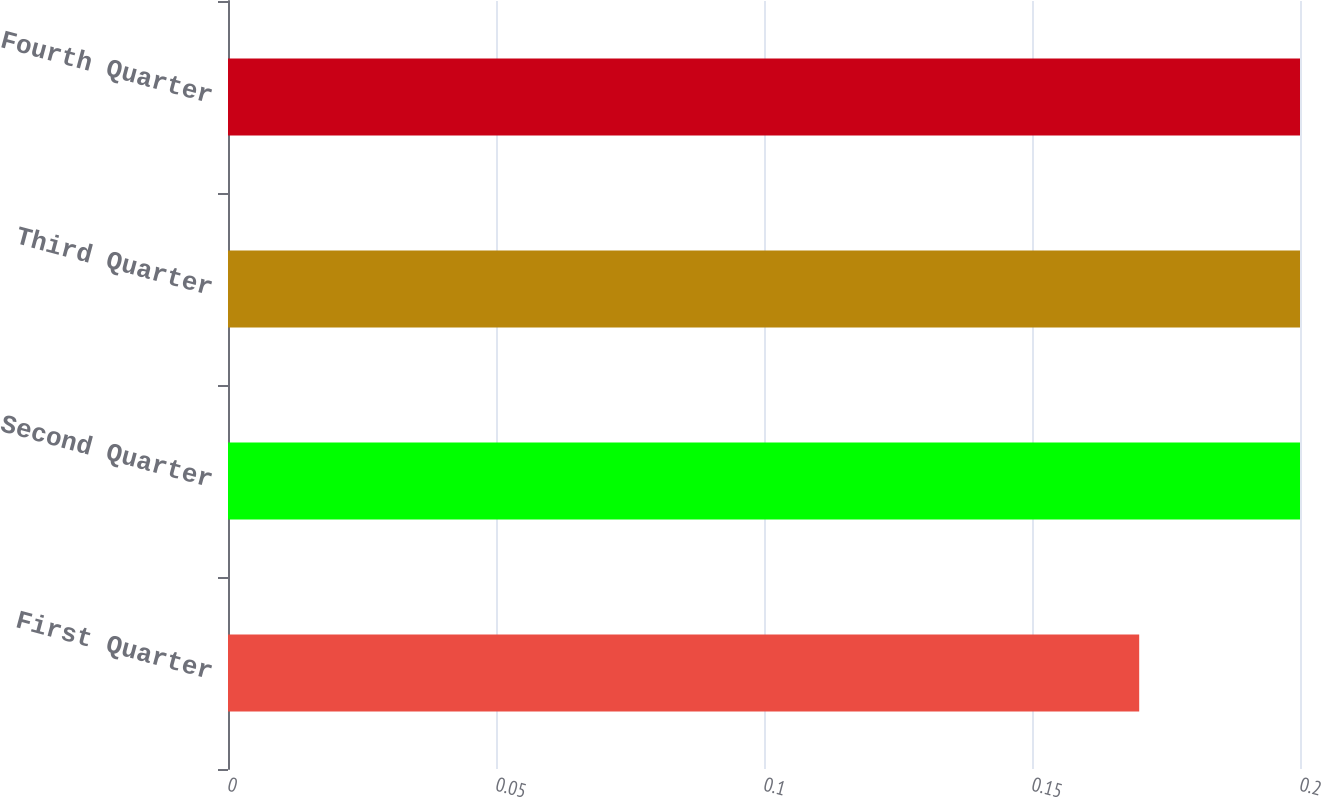<chart> <loc_0><loc_0><loc_500><loc_500><bar_chart><fcel>First Quarter<fcel>Second Quarter<fcel>Third Quarter<fcel>Fourth Quarter<nl><fcel>0.17<fcel>0.2<fcel>0.2<fcel>0.2<nl></chart> 